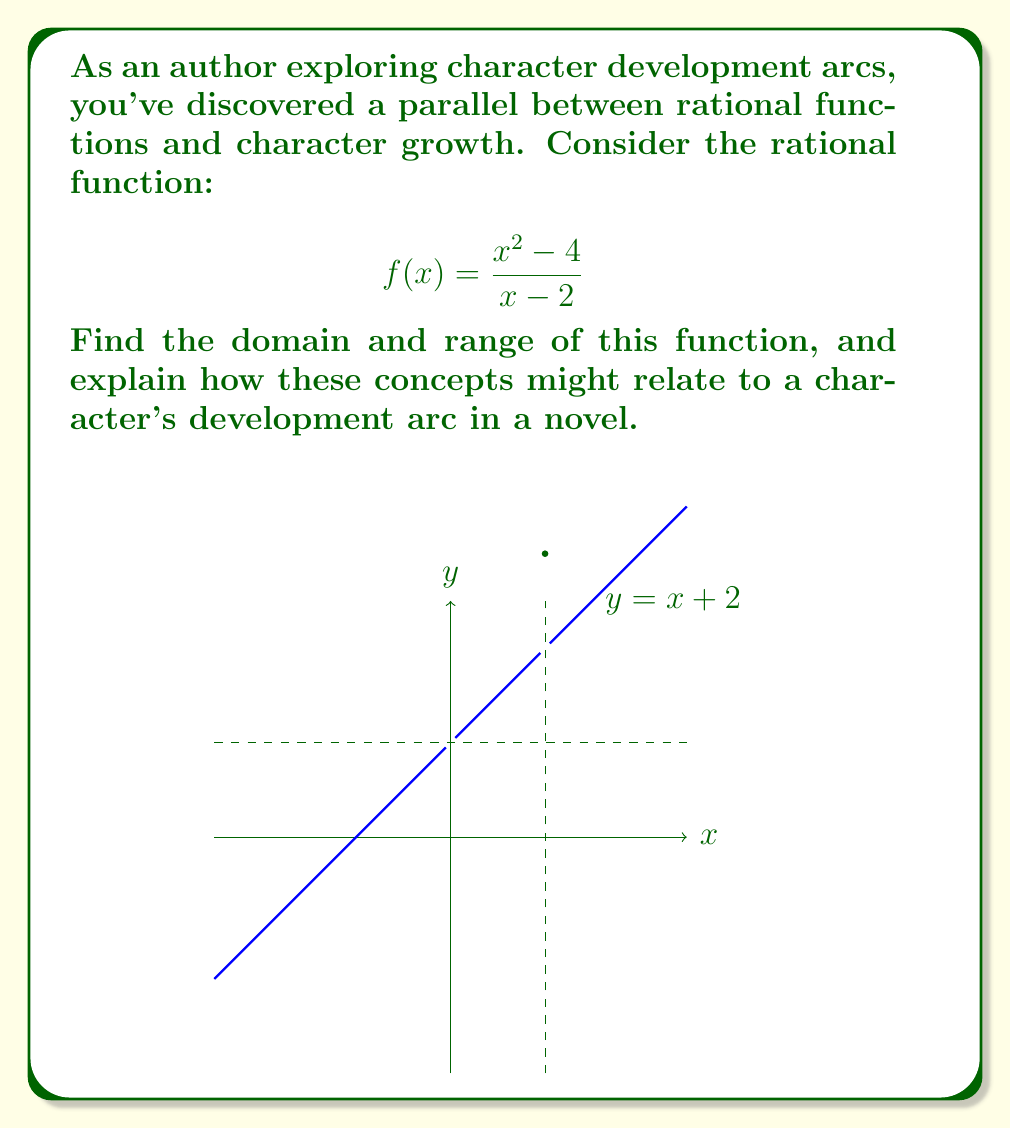Solve this math problem. Let's approach this step-by-step:

1) Domain:
   The domain of a rational function includes all real numbers except those that make the denominator zero.
   Set the denominator to zero and solve:
   $x - 2 = 0$
   $x = 2$
   Therefore, the domain is all real numbers except 2, or $\mathbb{R} \setminus \{2\}$.

2) Range:
   To find the range, let's simplify the function:
   $$f(x) = \frac{x^2 - 4}{x - 2} = \frac{(x+2)(x-2)}{x-2} = x + 2$$
   This simplifies to a linear function, $y = x + 2$, for all $x \neq 2$.
   The range of this linear function is all real numbers, or $\mathbb{R}$.

3) Relation to character development:
   - The domain represents the "input" or experiences a character encounters (excluding the undefined point, which could represent a pivotal, transformative moment).
   - The range represents the "output" or the character's growth and change.
   - The linear relationship (y = x + 2) suggests steady, consistent growth.
   - The undefined point (x = 2) could represent a crucial turning point in the character's arc.
   - The vertical asymptote at x = 2 might symbolize a moment of significant change or revelation.
   - The horizontal asymptote (which doesn't exist here) could represent a character's ultimate potential or limitation.

This rational function, with its linear simplification, represents a character who grows steadily with experience, has a defining moment (at x = 2), but continues to develop without upper bound, suggesting unlimited potential for growth.
Answer: Domain: $\mathbb{R} \setminus \{2\}$, Range: $\mathbb{R}$ 